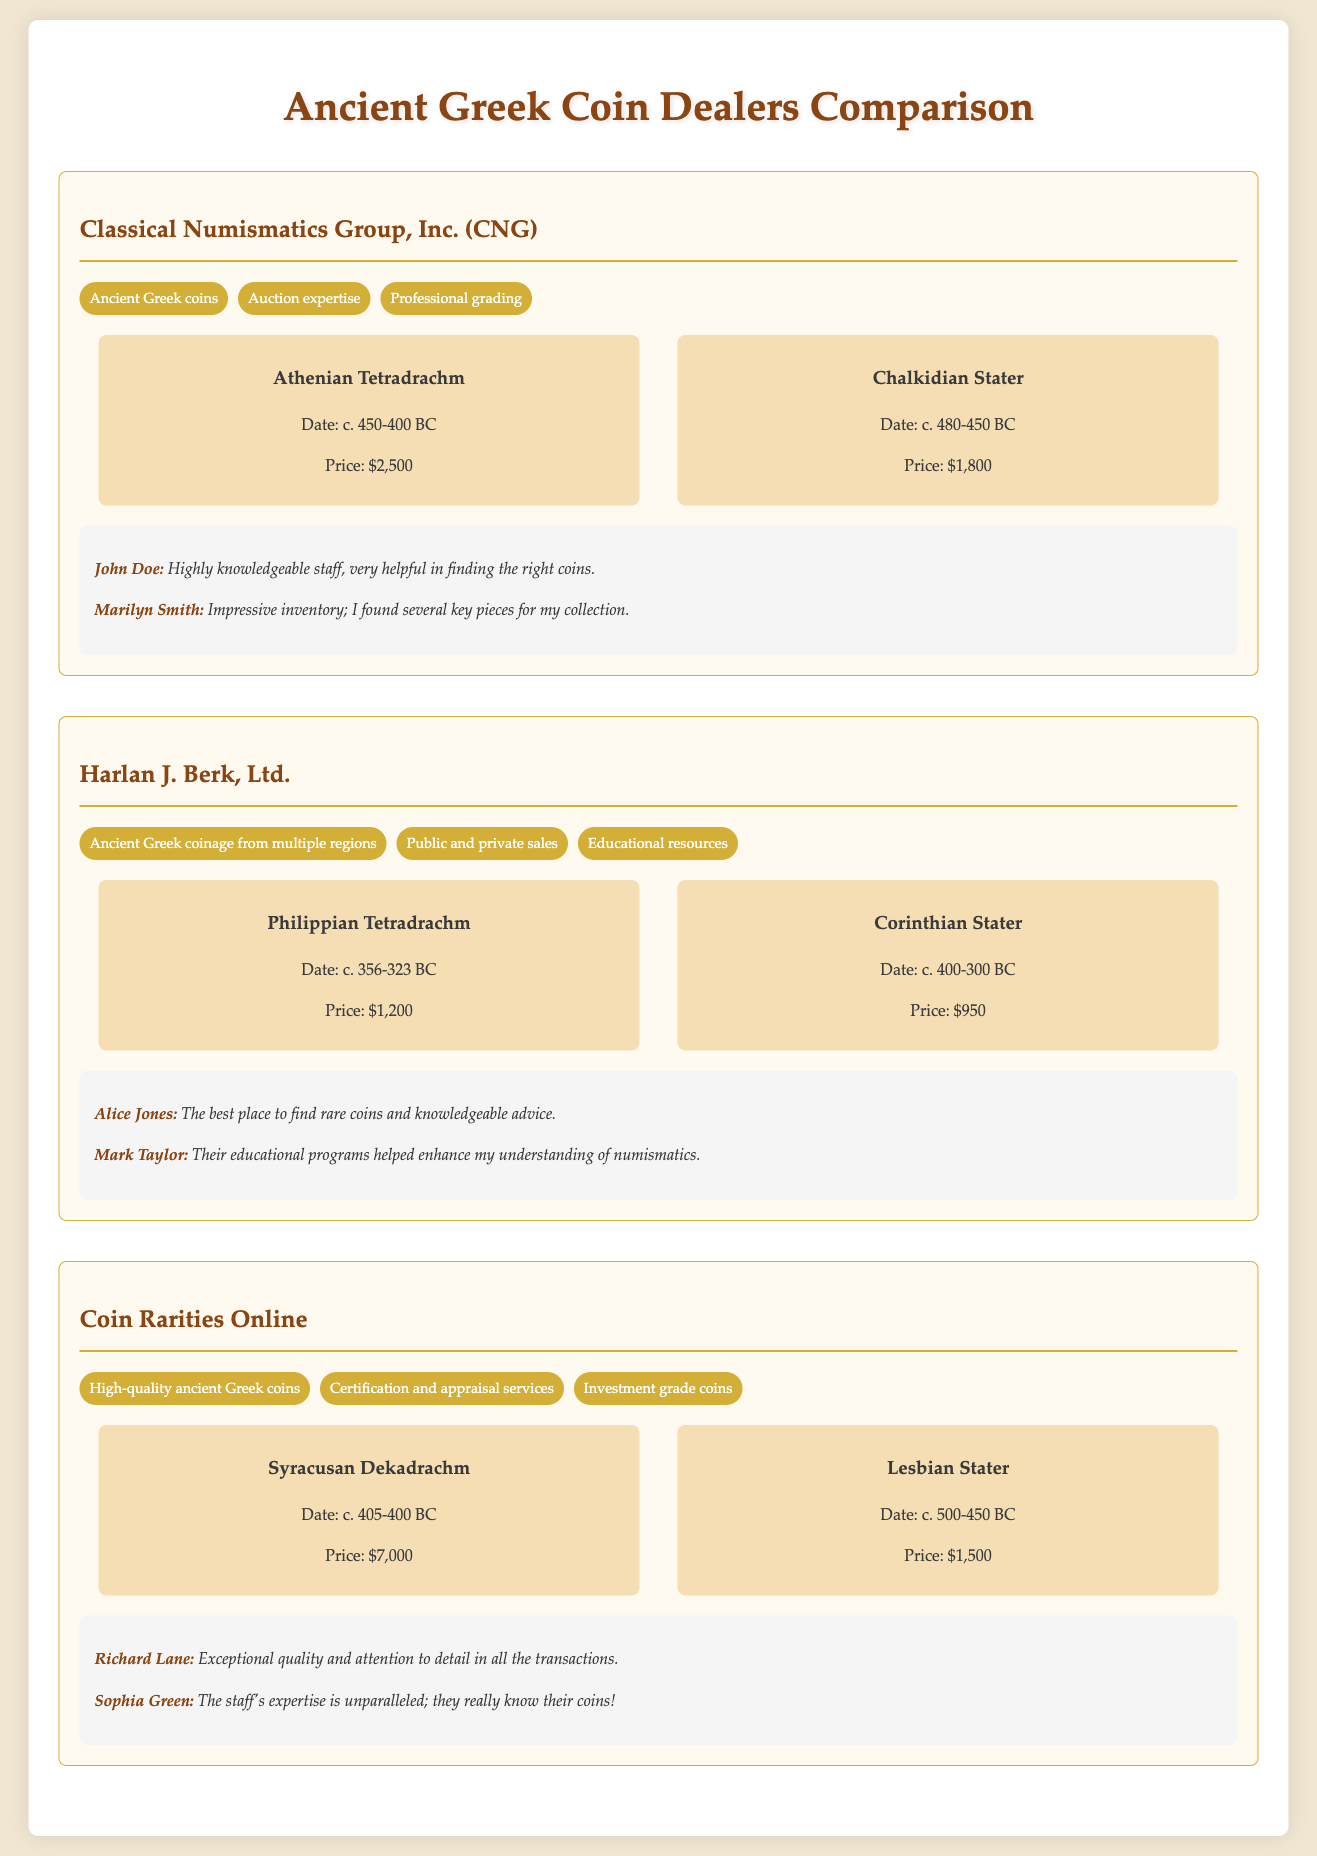What is the specialty of Classical Numismatics Group, Inc.? The specialty of Classical Numismatics Group, Inc. includes ancient Greek coins, auction expertise, and professional grading.
Answer: Ancient Greek coins What is the price of the Syracusan Dekadrachm? The price listed for the Syracusan Dekadrachm in the document is $7,000.
Answer: $7,000 Who reviewed Harlan J. Berk, Ltd.? The individuals who reviewed Harlan J. Berk, Ltd. include Alice Jones and Mark Taylor.
Answer: Alice Jones and Mark Taylor What type of coins does Coin Rarities Online specialize in? Coin Rarities Online specializes in high-quality ancient Greek coins, certification and appraisal services, and investment grade coins.
Answer: High-quality ancient Greek coins How much is the Chalkidian Stater priced at? The price for the Chalkidian Stater is indicated as $1,800 in the document.
Answer: $1,800 What is the completion date for the Athenian Tetradrachm? The document states that the Athenian Tetradrachm dates back to around 450-400 BC.
Answer: c. 450-400 BC Which dealer offers educational resources? The dealer that offers educational resources is Harlan J. Berk, Ltd.
Answer: Harlan J. Berk, Ltd What customer review mentions "helpful in finding the right coins"? The review by John Doe mentions being "highly knowledgeable staff, very helpful in finding the right coins."
Answer: "highly knowledgeable staff, very helpful in finding the right coins" 